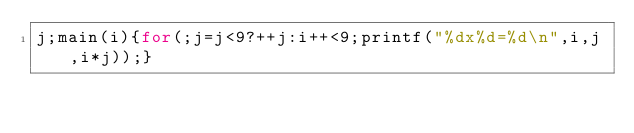Convert code to text. <code><loc_0><loc_0><loc_500><loc_500><_C_>j;main(i){for(;j=j<9?++j:i++<9;printf("%dx%d=%d\n",i,j,i*j));}</code> 